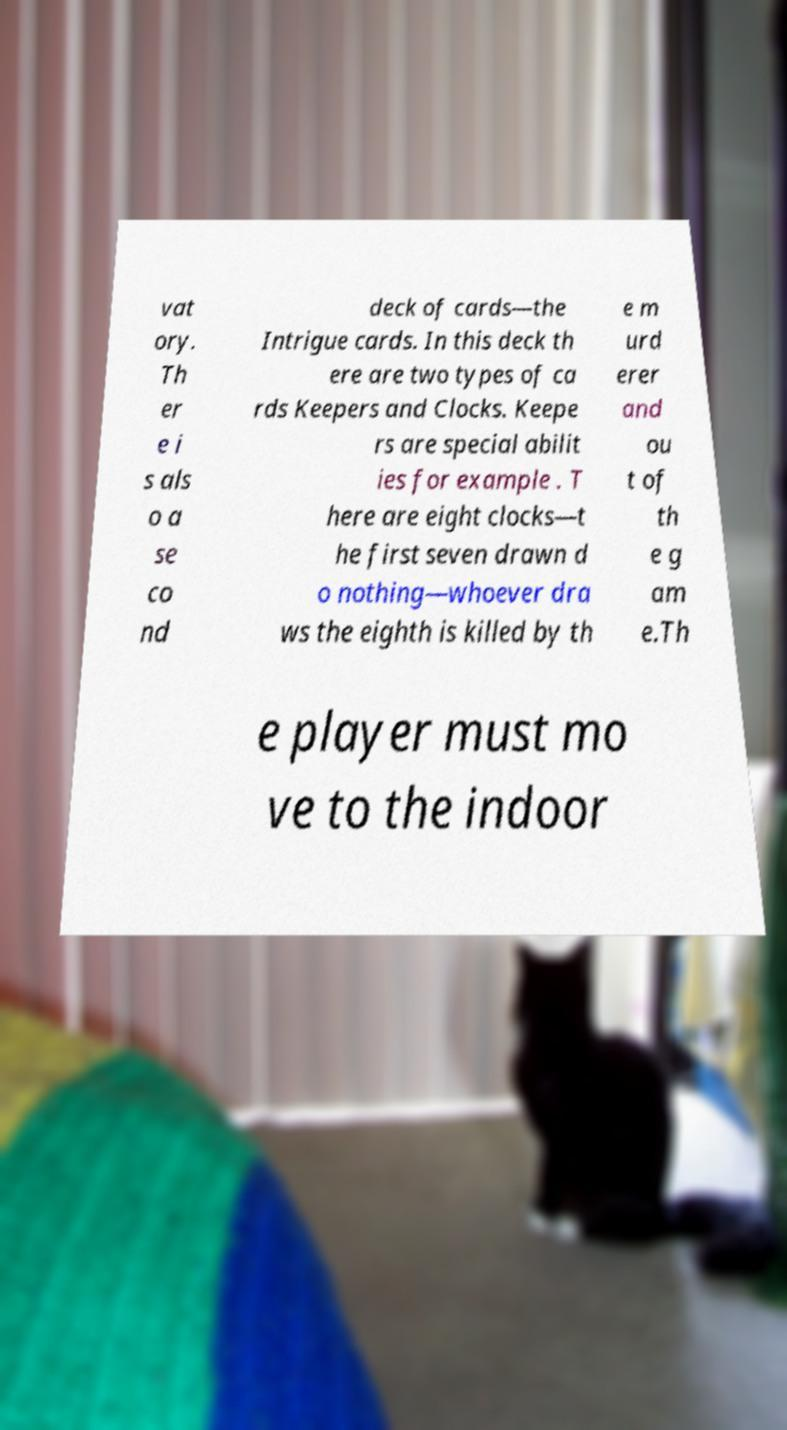Can you accurately transcribe the text from the provided image for me? vat ory. Th er e i s als o a se co nd deck of cards—the Intrigue cards. In this deck th ere are two types of ca rds Keepers and Clocks. Keepe rs are special abilit ies for example . T here are eight clocks—t he first seven drawn d o nothing—whoever dra ws the eighth is killed by th e m urd erer and ou t of th e g am e.Th e player must mo ve to the indoor 